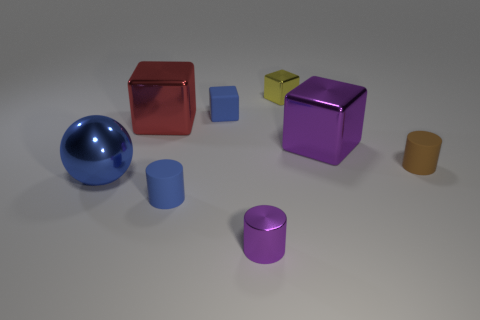What material is the other block that is the same size as the purple block?
Make the answer very short. Metal. The tiny yellow thing has what shape?
Provide a succinct answer. Cube. What number of cyan things are either small objects or big shiny objects?
Offer a very short reply. 0. The blue thing that is made of the same material as the big purple thing is what size?
Offer a very short reply. Large. Is the small cylinder that is behind the large blue shiny object made of the same material as the big block that is on the right side of the purple cylinder?
Offer a terse response. No. How many cylinders are large green matte objects or small purple things?
Your answer should be compact. 1. What number of small blue cylinders are to the right of the blue object that is behind the large cube that is left of the metallic cylinder?
Your answer should be very brief. 0. There is a small blue object that is the same shape as the big red object; what material is it?
Provide a short and direct response. Rubber. Are there any other things that are made of the same material as the big blue thing?
Your answer should be very brief. Yes. What is the color of the big thing that is on the right side of the red metal cube?
Keep it short and to the point. Purple. 